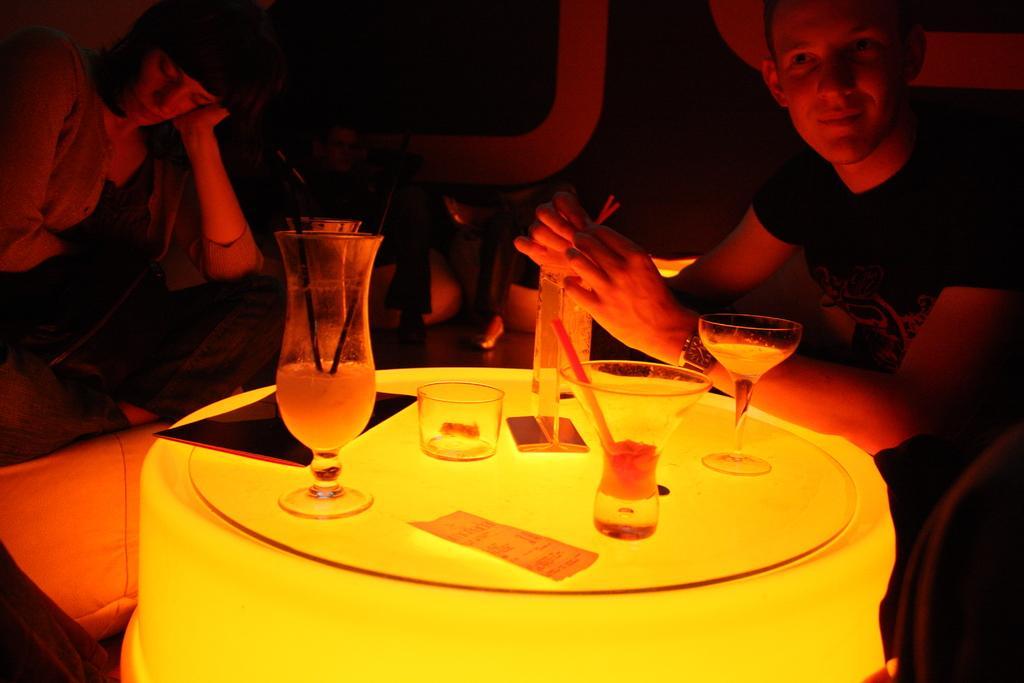Can you describe this image briefly? In this image I see a woman and a man who are sitting in front of a table and there are glasses on it. I can also see this man is holding the straw. 